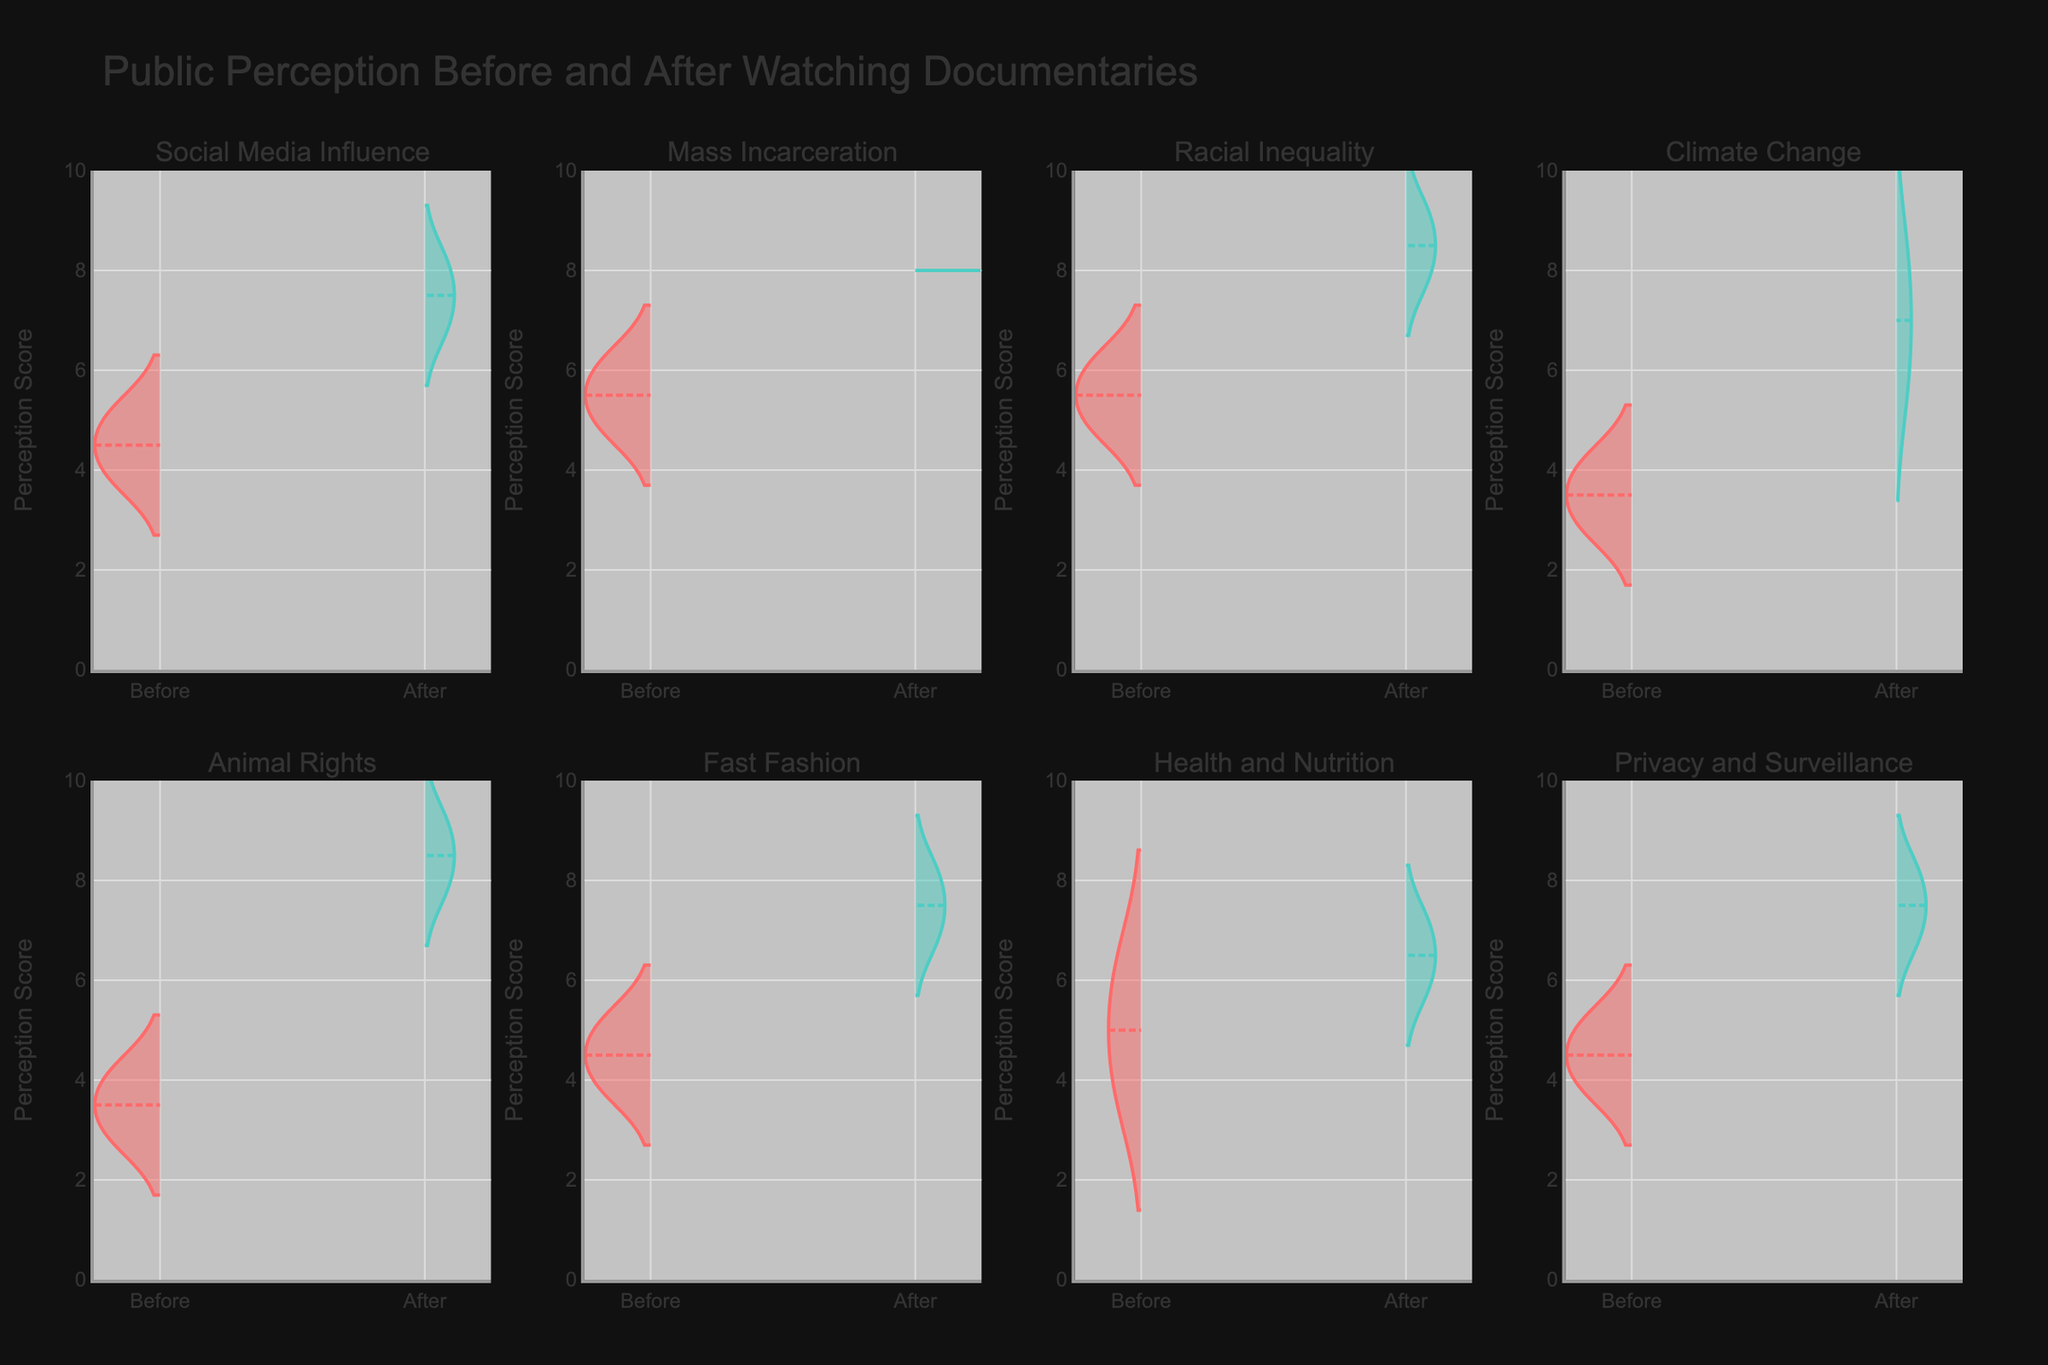What is the title of this figure? The title is located at the top of the figure. It reads "Public Perception Before and After Watching Documentaries."
Answer: Public Perception Before and After Watching Documentaries Which social issue had the highest increase in public perception after watching the documentary? By comparing the "Before" and "After" violin plots for each social issue, we see that "Animal Rights" had the highest increase, from a median of about 4 before to about 9 after.
Answer: Animal Rights How many social issues are displayed in this figure? The subplot titles list each social issue. Counting these, there are 8 social issues represented in the figure.
Answer: 8 Which documentary's perception increased the most on average after watching it? Compare the positions of the mean lines in both "Before" and "After" plots across all subplots. "Blackfish" (Animal Rights) shows the most significant average increase (from 4 to 9).
Answer: Blackfish What is the range of the perception scores on the y-axis? Observing the y-axes of the subplots, the range extends from 0 to 10.
Answer: 0 to 10 Which social issue had the smallest change in public perception? To find this, compare the distances between the "Before" and "After" mean lines. "Health and Nutrition" (Super Size Me) changed the least, from around 5 to 6 on average.
Answer: Health and Nutrition Which plot(s) have all the data points above the mid-point of the y-axis after watching the documentary? Look at the "After" plots and see if all points are above 5 (mid-point). Both "Animal Rights" and "Mass Incarceration" plots meet this criterion.
Answer: Animal Rights, Mass Incarceration What is common about the violin plots across all social issues before watching the documentaries? Observing all the "Before" plots, they all have a narrower spread compared to the "After" plots, indicating more concentrated perceptions initially.
Answer: Narrower spread before Which social issue(s) show symmetry in the distribution of scores after watching the documentary? Symmetry in violin plots is seen when the shape is mirror-imaged around the mean line. The "Mass Incarceration" plot (13th) shows this symmetry.
Answer: Mass Incarceration How can you describe the change in public perception for "Climate Change"? By comparing "Before" and "After" plots for Climate Change, the median perception score increases significantly from 3-4 to 6-8 after watching "Before The Flood".
Answer: Significant increase 